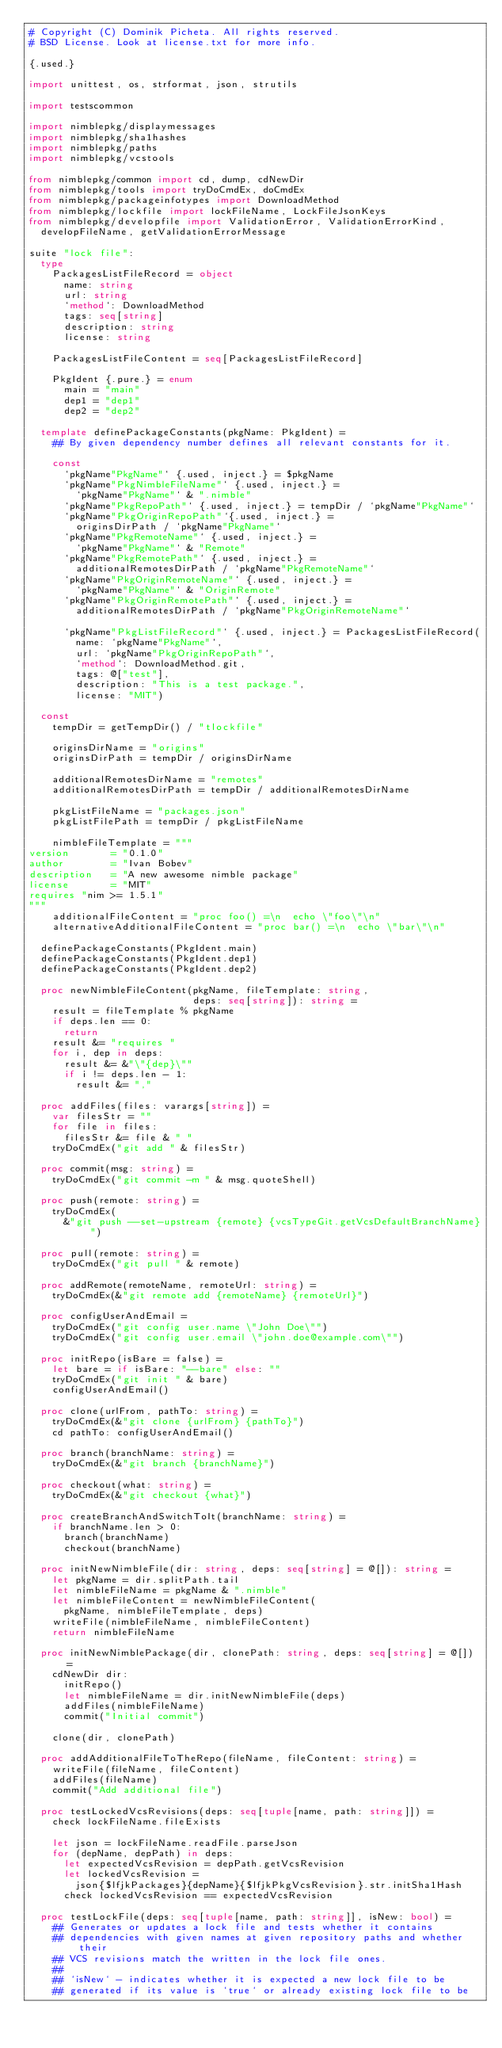<code> <loc_0><loc_0><loc_500><loc_500><_Nim_># Copyright (C) Dominik Picheta. All rights reserved.
# BSD License. Look at license.txt for more info.

{.used.}

import unittest, os, strformat, json, strutils

import testscommon

import nimblepkg/displaymessages
import nimblepkg/sha1hashes
import nimblepkg/paths
import nimblepkg/vcstools

from nimblepkg/common import cd, dump, cdNewDir
from nimblepkg/tools import tryDoCmdEx, doCmdEx
from nimblepkg/packageinfotypes import DownloadMethod
from nimblepkg/lockfile import lockFileName, LockFileJsonKeys
from nimblepkg/developfile import ValidationError, ValidationErrorKind,
  developFileName, getValidationErrorMessage

suite "lock file":
  type
    PackagesListFileRecord = object
      name: string
      url: string
      `method`: DownloadMethod
      tags: seq[string]
      description: string
      license: string

    PackagesListFileContent = seq[PackagesListFileRecord]

    PkgIdent {.pure.} = enum
      main = "main"
      dep1 = "dep1"
      dep2 = "dep2"

  template definePackageConstants(pkgName: PkgIdent) =
    ## By given dependency number defines all relevant constants for it.

    const
      `pkgName"PkgName"` {.used, inject.} = $pkgName
      `pkgName"PkgNimbleFileName"` {.used, inject.} =
        `pkgName"PkgName"` & ".nimble"
      `pkgName"PkgRepoPath"` {.used, inject.} = tempDir / `pkgName"PkgName"`
      `pkgName"PkgOriginRepoPath"`{.used, inject.} =
        originsDirPath / `pkgName"PkgName"`
      `pkgName"PkgRemoteName"` {.used, inject.} = 
        `pkgName"PkgName"` & "Remote"
      `pkgName"PkgRemotePath"` {.used, inject.} =
        additionalRemotesDirPath / `pkgName"PkgRemoteName"`
      `pkgName"PkgOriginRemoteName"` {.used, inject.} =
        `pkgName"PkgName"` & "OriginRemote"
      `pkgName"PkgOriginRemotePath"` {.used, inject.} =
        additionalRemotesDirPath / `pkgName"PkgOriginRemoteName"`

      `pkgName"PkgListFileRecord"` {.used, inject.} = PackagesListFileRecord(
        name: `pkgName"PkgName"`,
        url: `pkgName"PkgOriginRepoPath"`,
        `method`: DownloadMethod.git,
        tags: @["test"],
        description: "This is a test package.",
        license: "MIT")

  const
    tempDir = getTempDir() / "tlockfile"

    originsDirName = "origins"
    originsDirPath = tempDir / originsDirName

    additionalRemotesDirName = "remotes"
    additionalRemotesDirPath = tempDir / additionalRemotesDirName

    pkgListFileName = "packages.json"
    pkgListFilePath = tempDir / pkgListFileName

    nimbleFileTemplate = """
version       = "0.1.0"
author        = "Ivan Bobev"
description   = "A new awesome nimble package"
license       = "MIT"
requires "nim >= 1.5.1"
"""
    additionalFileContent = "proc foo() =\n  echo \"foo\"\n"
    alternativeAdditionalFileContent = "proc bar() =\n  echo \"bar\"\n"

  definePackageConstants(PkgIdent.main)
  definePackageConstants(PkgIdent.dep1)
  definePackageConstants(PkgIdent.dep2)

  proc newNimbleFileContent(pkgName, fileTemplate: string,
                            deps: seq[string]): string =
    result = fileTemplate % pkgName
    if deps.len == 0:
      return
    result &= "requires "
    for i, dep in deps:
      result &= &"\"{dep}\""
      if i != deps.len - 1:
        result &= ","

  proc addFiles(files: varargs[string]) =
    var filesStr = ""
    for file in files:
      filesStr &= file & " "
    tryDoCmdEx("git add " & filesStr)

  proc commit(msg: string) =
    tryDoCmdEx("git commit -m " & msg.quoteShell)

  proc push(remote: string) =
    tryDoCmdEx(
      &"git push --set-upstream {remote} {vcsTypeGit.getVcsDefaultBranchName}")

  proc pull(remote: string) =
    tryDoCmdEx("git pull " & remote)

  proc addRemote(remoteName, remoteUrl: string) =
    tryDoCmdEx(&"git remote add {remoteName} {remoteUrl}")

  proc configUserAndEmail =
    tryDoCmdEx("git config user.name \"John Doe\"")
    tryDoCmdEx("git config user.email \"john.doe@example.com\"")

  proc initRepo(isBare = false) =
    let bare = if isBare: "--bare" else: ""
    tryDoCmdEx("git init " & bare)
    configUserAndEmail()

  proc clone(urlFrom, pathTo: string) =
    tryDoCmdEx(&"git clone {urlFrom} {pathTo}")
    cd pathTo: configUserAndEmail()

  proc branch(branchName: string) =
    tryDoCmdEx(&"git branch {branchName}")

  proc checkout(what: string) =
    tryDoCmdEx(&"git checkout {what}")

  proc createBranchAndSwitchToIt(branchName: string) =
    if branchName.len > 0:
      branch(branchName)
      checkout(branchName)

  proc initNewNimbleFile(dir: string, deps: seq[string] = @[]): string =
    let pkgName = dir.splitPath.tail
    let nimbleFileName = pkgName & ".nimble"
    let nimbleFileContent = newNimbleFileContent(
      pkgName, nimbleFileTemplate, deps)
    writeFile(nimbleFileName, nimbleFileContent)
    return nimbleFileName

  proc initNewNimblePackage(dir, clonePath: string, deps: seq[string] = @[]) =
    cdNewDir dir:
      initRepo()
      let nimbleFileName = dir.initNewNimbleFile(deps)
      addFiles(nimbleFileName)
      commit("Initial commit")

    clone(dir, clonePath)

  proc addAdditionalFileToTheRepo(fileName, fileContent: string) =
    writeFile(fileName, fileContent)
    addFiles(fileName)
    commit("Add additional file")

  proc testLockedVcsRevisions(deps: seq[tuple[name, path: string]]) =
    check lockFileName.fileExists

    let json = lockFileName.readFile.parseJson
    for (depName, depPath) in deps:
      let expectedVcsRevision = depPath.getVcsRevision
      let lockedVcsRevision =
        json{$lfjkPackages}{depName}{$lfjkPkgVcsRevision}.str.initSha1Hash
      check lockedVcsRevision == expectedVcsRevision

  proc testLockFile(deps: seq[tuple[name, path: string]], isNew: bool) =
    ## Generates or updates a lock file and tests whether it contains
    ## dependencies with given names at given repository paths and whether their
    ## VCS revisions match the written in the lock file ones.
    ##
    ## `isNew` - indicates whether it is expected a new lock file to be
    ## generated if its value is `true` or already existing lock file to be</code> 